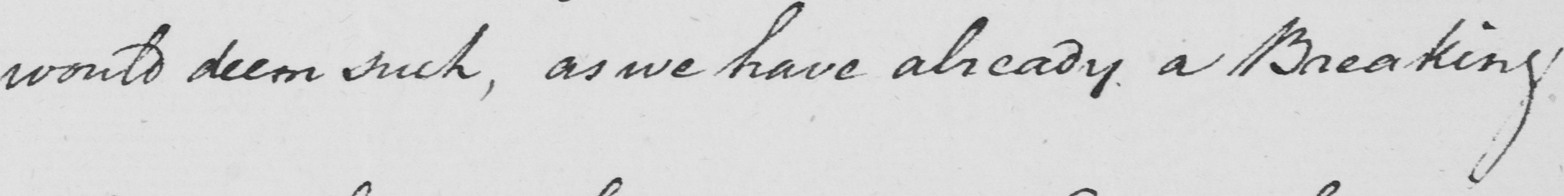Please provide the text content of this handwritten line. would deem such , as we have already a Breaking 